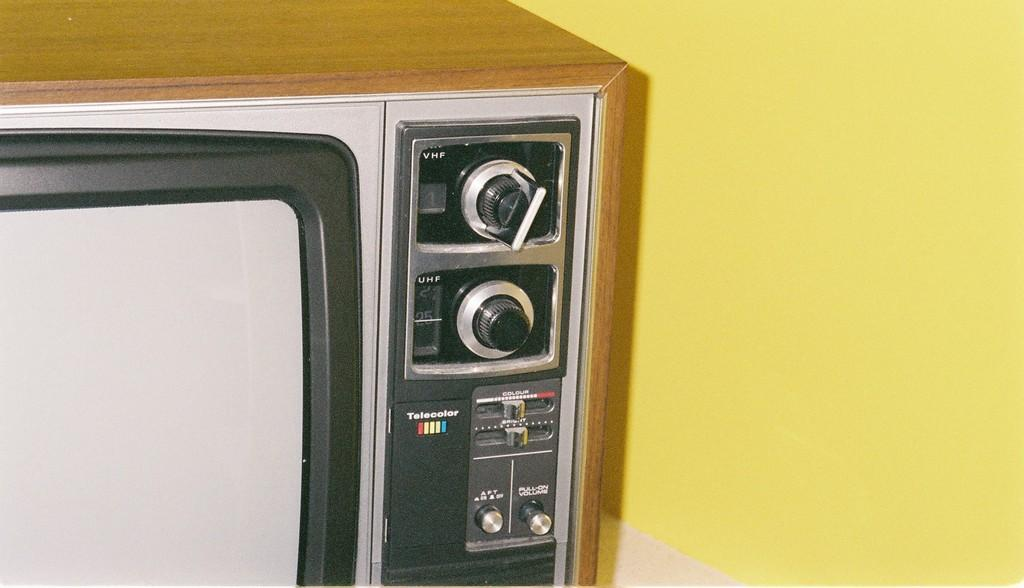Provide a one-sentence caption for the provided image. A picture of an old style TV that has the word technicolor written on it. 